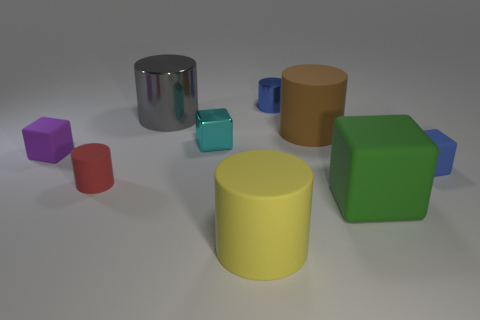Subtract all gray cylinders. How many cylinders are left? 4 Subtract all blue cylinders. How many cylinders are left? 4 Subtract all green cylinders. Subtract all gray balls. How many cylinders are left? 5 Add 1 small metallic objects. How many objects exist? 10 Subtract all blocks. How many objects are left? 5 Add 4 tiny red metal cylinders. How many tiny red metal cylinders exist? 4 Subtract 1 gray cylinders. How many objects are left? 8 Subtract all yellow rubber cylinders. Subtract all tiny purple rubber balls. How many objects are left? 8 Add 2 big gray objects. How many big gray objects are left? 3 